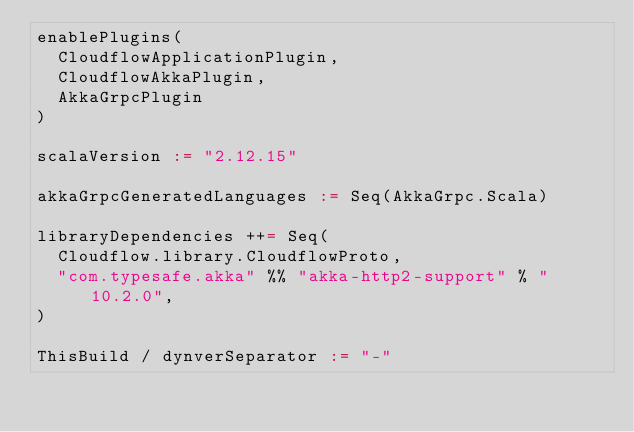Convert code to text. <code><loc_0><loc_0><loc_500><loc_500><_Scala_>enablePlugins(
  CloudflowApplicationPlugin,
  CloudflowAkkaPlugin,
  AkkaGrpcPlugin
)

scalaVersion := "2.12.15"

akkaGrpcGeneratedLanguages := Seq(AkkaGrpc.Scala)

libraryDependencies ++= Seq(
  Cloudflow.library.CloudflowProto,
  "com.typesafe.akka" %% "akka-http2-support" % "10.2.0",
)

ThisBuild / dynverSeparator := "-"
</code> 